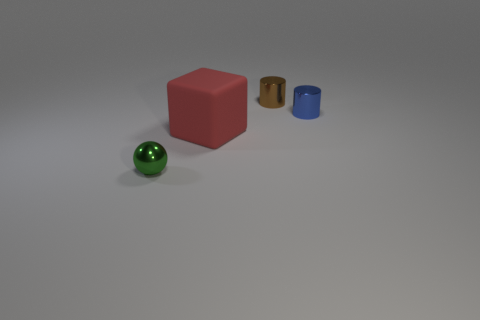Add 1 small objects. How many objects exist? 5 Subtract all spheres. How many objects are left? 3 Add 3 big red matte objects. How many big red matte objects are left? 4 Add 2 tiny purple balls. How many tiny purple balls exist? 2 Subtract 0 brown spheres. How many objects are left? 4 Subtract all red things. Subtract all tiny blue cylinders. How many objects are left? 2 